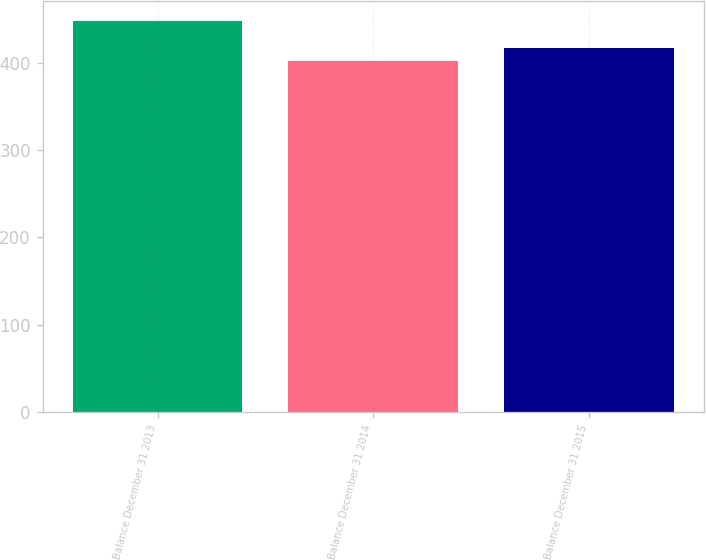Convert chart to OTSL. <chart><loc_0><loc_0><loc_500><loc_500><bar_chart><fcel>Balance December 31 2013<fcel>Balance December 31 2014<fcel>Balance December 31 2015<nl><fcel>448.3<fcel>401.9<fcel>417.7<nl></chart> 